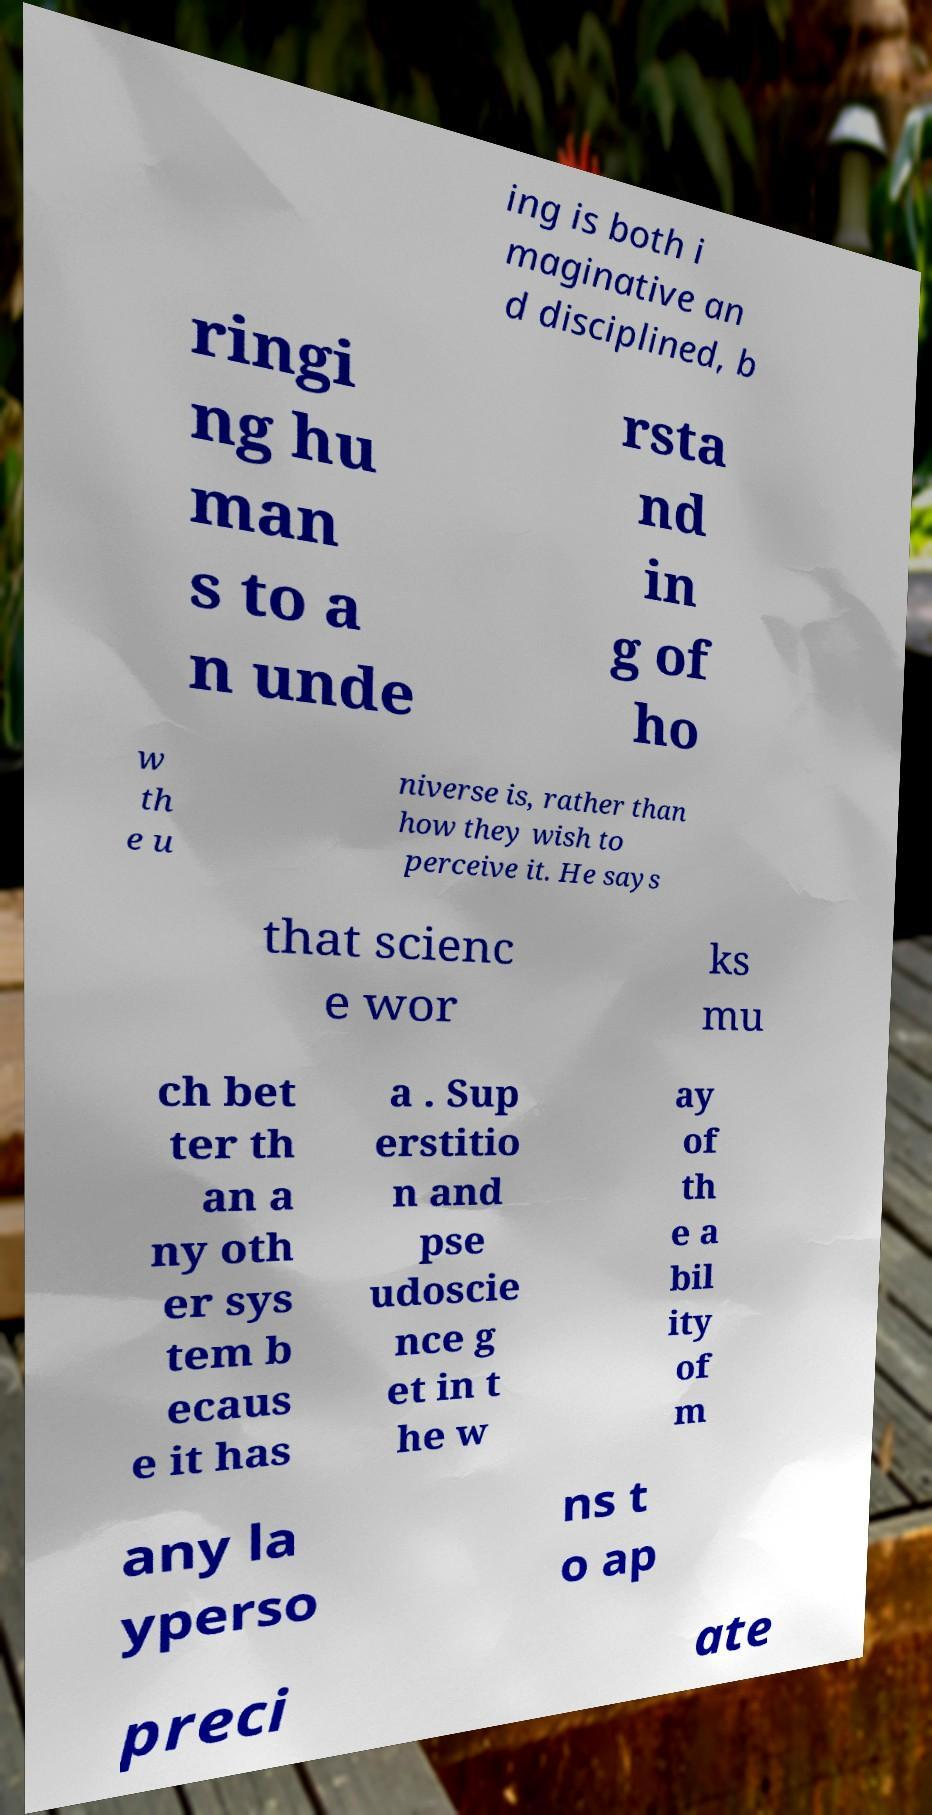Please identify and transcribe the text found in this image. ing is both i maginative an d disciplined, b ringi ng hu man s to a n unde rsta nd in g of ho w th e u niverse is, rather than how they wish to perceive it. He says that scienc e wor ks mu ch bet ter th an a ny oth er sys tem b ecaus e it has a . Sup erstitio n and pse udoscie nce g et in t he w ay of th e a bil ity of m any la yperso ns t o ap preci ate 